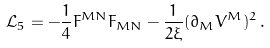Convert formula to latex. <formula><loc_0><loc_0><loc_500><loc_500>\mathcal { L } _ { 5 } = - \frac { 1 } { 4 } F ^ { M N } F _ { M N } - \frac { 1 } { 2 \xi } ( \partial _ { M } V ^ { M } ) ^ { 2 } \, .</formula> 